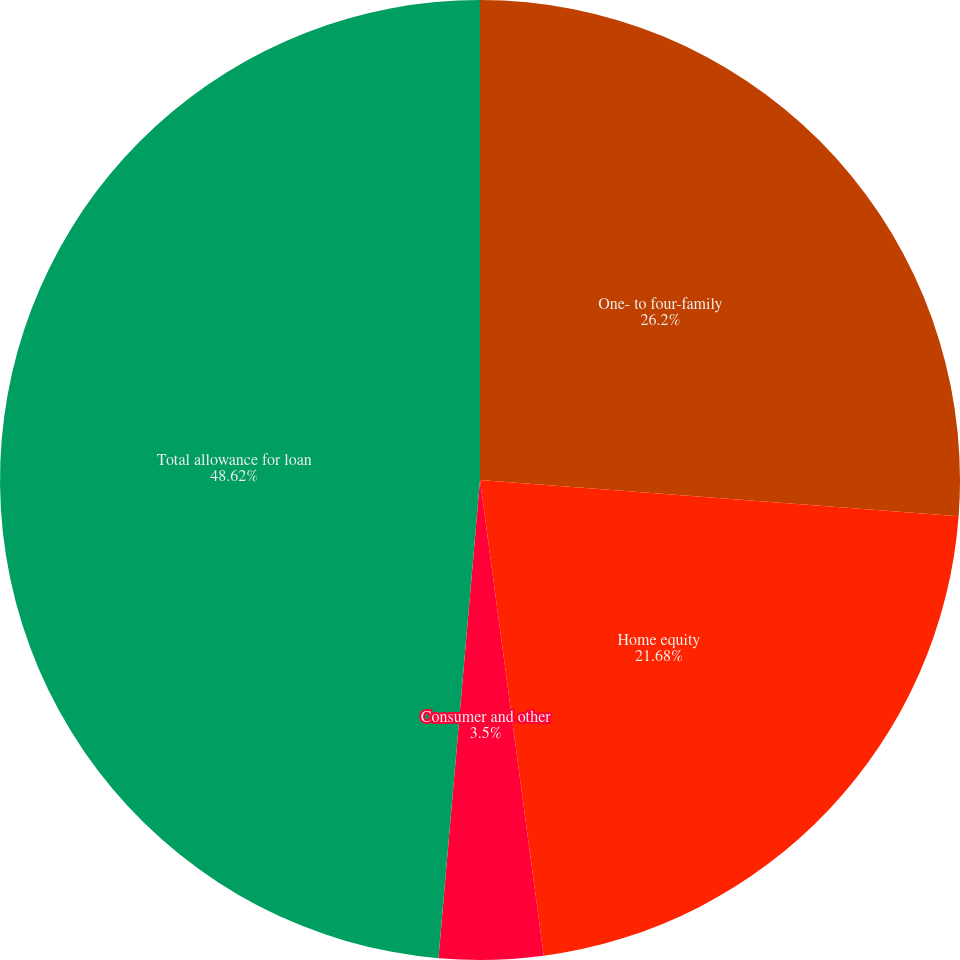<chart> <loc_0><loc_0><loc_500><loc_500><pie_chart><fcel>One- to four-family<fcel>Home equity<fcel>Consumer and other<fcel>Total allowance for loan<nl><fcel>26.2%<fcel>21.68%<fcel>3.5%<fcel>48.62%<nl></chart> 